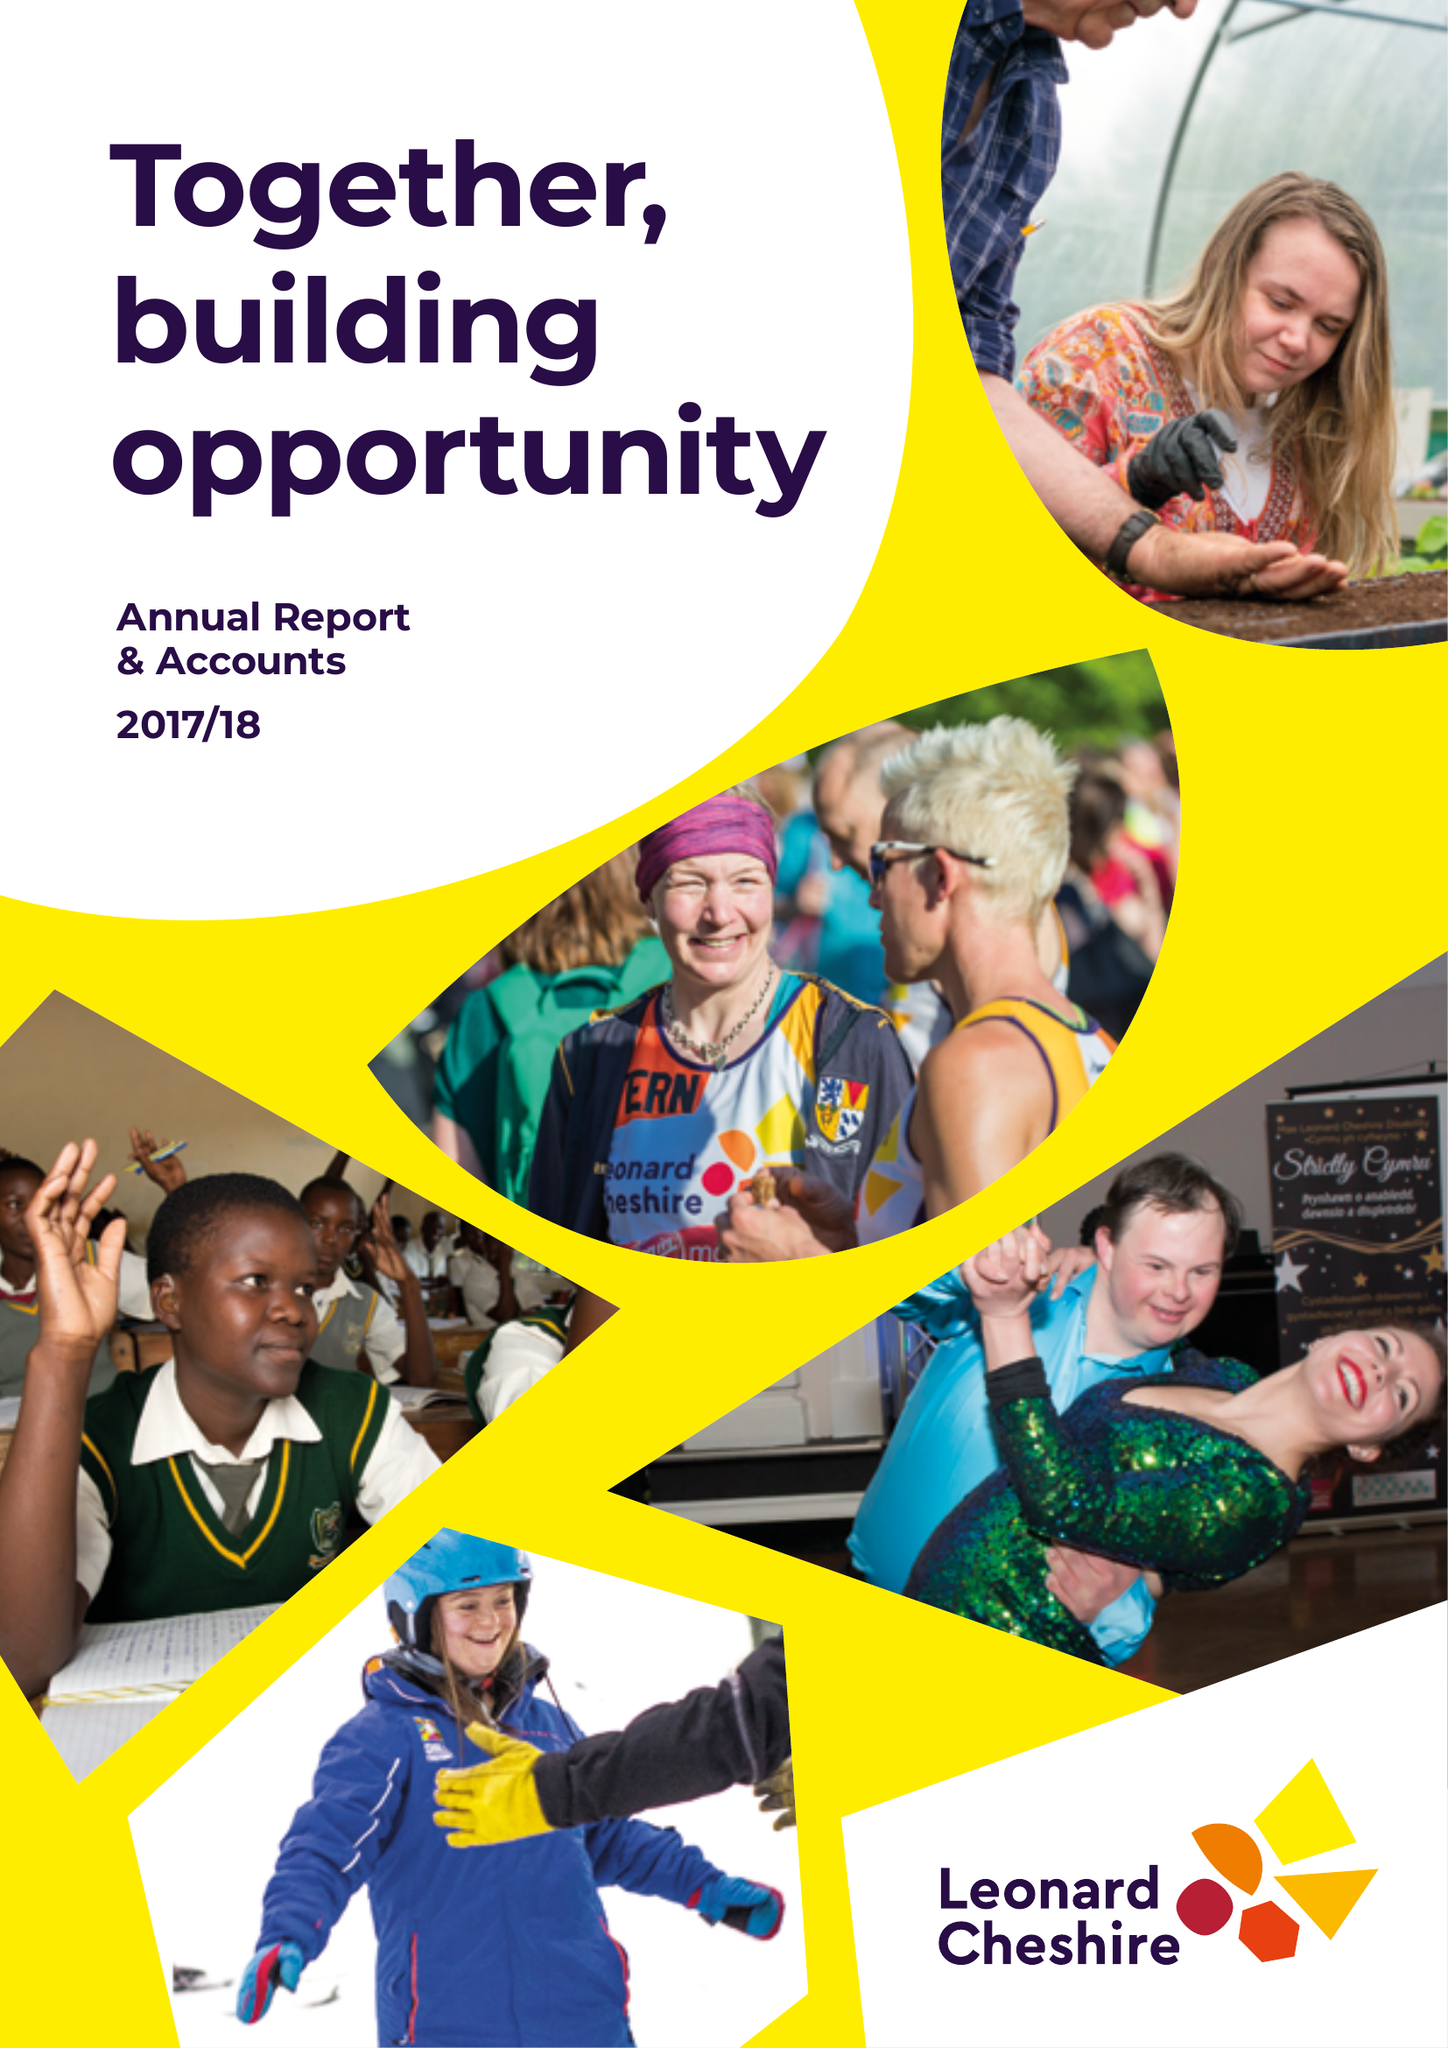What is the value for the spending_annually_in_british_pounds?
Answer the question using a single word or phrase. 171531000.00 